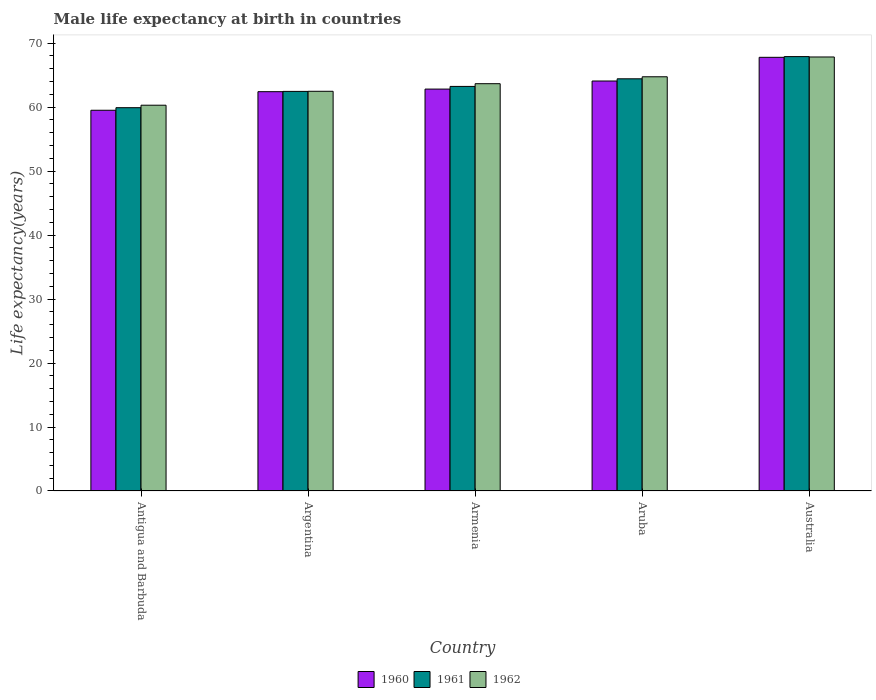How many different coloured bars are there?
Your answer should be very brief. 3. Are the number of bars per tick equal to the number of legend labels?
Offer a terse response. Yes. Are the number of bars on each tick of the X-axis equal?
Give a very brief answer. Yes. How many bars are there on the 2nd tick from the right?
Your answer should be compact. 3. What is the label of the 2nd group of bars from the left?
Offer a terse response. Argentina. In how many cases, is the number of bars for a given country not equal to the number of legend labels?
Provide a succinct answer. 0. What is the male life expectancy at birth in 1962 in Aruba?
Make the answer very short. 64.75. Across all countries, what is the maximum male life expectancy at birth in 1960?
Offer a terse response. 67.79. Across all countries, what is the minimum male life expectancy at birth in 1960?
Offer a very short reply. 59.51. In which country was the male life expectancy at birth in 1961 maximum?
Provide a short and direct response. Australia. In which country was the male life expectancy at birth in 1961 minimum?
Your answer should be compact. Antigua and Barbuda. What is the total male life expectancy at birth in 1962 in the graph?
Give a very brief answer. 319.03. What is the difference between the male life expectancy at birth in 1960 in Aruba and that in Australia?
Provide a succinct answer. -3.7. What is the difference between the male life expectancy at birth in 1961 in Aruba and the male life expectancy at birth in 1962 in Argentina?
Offer a terse response. 1.95. What is the average male life expectancy at birth in 1960 per country?
Give a very brief answer. 63.32. What is the difference between the male life expectancy at birth of/in 1962 and male life expectancy at birth of/in 1961 in Armenia?
Make the answer very short. 0.42. What is the ratio of the male life expectancy at birth in 1961 in Antigua and Barbuda to that in Argentina?
Provide a short and direct response. 0.96. Is the male life expectancy at birth in 1961 in Argentina less than that in Aruba?
Make the answer very short. Yes. What is the difference between the highest and the second highest male life expectancy at birth in 1962?
Offer a very short reply. -3.09. What is the difference between the highest and the lowest male life expectancy at birth in 1962?
Offer a terse response. 7.54. Is the sum of the male life expectancy at birth in 1961 in Argentina and Australia greater than the maximum male life expectancy at birth in 1962 across all countries?
Provide a succinct answer. Yes. What does the 3rd bar from the left in Australia represents?
Provide a succinct answer. 1962. What does the 3rd bar from the right in Australia represents?
Your answer should be compact. 1960. Is it the case that in every country, the sum of the male life expectancy at birth in 1962 and male life expectancy at birth in 1961 is greater than the male life expectancy at birth in 1960?
Provide a short and direct response. Yes. How many bars are there?
Your answer should be very brief. 15. Are all the bars in the graph horizontal?
Offer a terse response. No. Does the graph contain any zero values?
Your response must be concise. No. Where does the legend appear in the graph?
Make the answer very short. Bottom center. How many legend labels are there?
Provide a short and direct response. 3. What is the title of the graph?
Ensure brevity in your answer.  Male life expectancy at birth in countries. Does "1965" appear as one of the legend labels in the graph?
Keep it short and to the point. No. What is the label or title of the Y-axis?
Your answer should be compact. Life expectancy(years). What is the Life expectancy(years) of 1960 in Antigua and Barbuda?
Make the answer very short. 59.51. What is the Life expectancy(years) in 1961 in Antigua and Barbuda?
Offer a terse response. 59.91. What is the Life expectancy(years) in 1962 in Antigua and Barbuda?
Provide a succinct answer. 60.3. What is the Life expectancy(years) in 1960 in Argentina?
Keep it short and to the point. 62.42. What is the Life expectancy(years) of 1961 in Argentina?
Make the answer very short. 62.46. What is the Life expectancy(years) in 1962 in Argentina?
Your answer should be compact. 62.48. What is the Life expectancy(years) in 1960 in Armenia?
Your response must be concise. 62.82. What is the Life expectancy(years) of 1961 in Armenia?
Your answer should be very brief. 63.24. What is the Life expectancy(years) of 1962 in Armenia?
Keep it short and to the point. 63.66. What is the Life expectancy(years) of 1960 in Aruba?
Keep it short and to the point. 64.08. What is the Life expectancy(years) in 1961 in Aruba?
Make the answer very short. 64.43. What is the Life expectancy(years) of 1962 in Aruba?
Provide a short and direct response. 64.75. What is the Life expectancy(years) of 1960 in Australia?
Offer a very short reply. 67.79. What is the Life expectancy(years) in 1961 in Australia?
Your response must be concise. 67.9. What is the Life expectancy(years) in 1962 in Australia?
Offer a terse response. 67.84. Across all countries, what is the maximum Life expectancy(years) of 1960?
Offer a terse response. 67.79. Across all countries, what is the maximum Life expectancy(years) in 1961?
Provide a succinct answer. 67.9. Across all countries, what is the maximum Life expectancy(years) of 1962?
Provide a short and direct response. 67.84. Across all countries, what is the minimum Life expectancy(years) of 1960?
Your answer should be very brief. 59.51. Across all countries, what is the minimum Life expectancy(years) in 1961?
Give a very brief answer. 59.91. Across all countries, what is the minimum Life expectancy(years) of 1962?
Make the answer very short. 60.3. What is the total Life expectancy(years) of 1960 in the graph?
Your answer should be very brief. 316.62. What is the total Life expectancy(years) of 1961 in the graph?
Provide a short and direct response. 317.94. What is the total Life expectancy(years) in 1962 in the graph?
Keep it short and to the point. 319.03. What is the difference between the Life expectancy(years) in 1960 in Antigua and Barbuda and that in Argentina?
Your answer should be compact. -2.9. What is the difference between the Life expectancy(years) in 1961 in Antigua and Barbuda and that in Argentina?
Ensure brevity in your answer.  -2.55. What is the difference between the Life expectancy(years) of 1962 in Antigua and Barbuda and that in Argentina?
Ensure brevity in your answer.  -2.18. What is the difference between the Life expectancy(years) of 1960 in Antigua and Barbuda and that in Armenia?
Ensure brevity in your answer.  -3.31. What is the difference between the Life expectancy(years) of 1961 in Antigua and Barbuda and that in Armenia?
Keep it short and to the point. -3.33. What is the difference between the Life expectancy(years) of 1962 in Antigua and Barbuda and that in Armenia?
Provide a short and direct response. -3.36. What is the difference between the Life expectancy(years) of 1960 in Antigua and Barbuda and that in Aruba?
Your answer should be compact. -4.57. What is the difference between the Life expectancy(years) of 1961 in Antigua and Barbuda and that in Aruba?
Offer a terse response. -4.52. What is the difference between the Life expectancy(years) in 1962 in Antigua and Barbuda and that in Aruba?
Offer a very short reply. -4.45. What is the difference between the Life expectancy(years) in 1960 in Antigua and Barbuda and that in Australia?
Provide a short and direct response. -8.27. What is the difference between the Life expectancy(years) of 1961 in Antigua and Barbuda and that in Australia?
Keep it short and to the point. -7.99. What is the difference between the Life expectancy(years) of 1962 in Antigua and Barbuda and that in Australia?
Offer a very short reply. -7.54. What is the difference between the Life expectancy(years) of 1960 in Argentina and that in Armenia?
Provide a succinct answer. -0.41. What is the difference between the Life expectancy(years) of 1961 in Argentina and that in Armenia?
Give a very brief answer. -0.78. What is the difference between the Life expectancy(years) in 1962 in Argentina and that in Armenia?
Provide a short and direct response. -1.19. What is the difference between the Life expectancy(years) in 1960 in Argentina and that in Aruba?
Your answer should be very brief. -1.67. What is the difference between the Life expectancy(years) in 1961 in Argentina and that in Aruba?
Give a very brief answer. -1.97. What is the difference between the Life expectancy(years) of 1962 in Argentina and that in Aruba?
Your answer should be compact. -2.27. What is the difference between the Life expectancy(years) in 1960 in Argentina and that in Australia?
Offer a terse response. -5.37. What is the difference between the Life expectancy(years) of 1961 in Argentina and that in Australia?
Keep it short and to the point. -5.44. What is the difference between the Life expectancy(years) in 1962 in Argentina and that in Australia?
Offer a terse response. -5.36. What is the difference between the Life expectancy(years) in 1960 in Armenia and that in Aruba?
Provide a short and direct response. -1.26. What is the difference between the Life expectancy(years) of 1961 in Armenia and that in Aruba?
Your response must be concise. -1.19. What is the difference between the Life expectancy(years) in 1962 in Armenia and that in Aruba?
Keep it short and to the point. -1.08. What is the difference between the Life expectancy(years) of 1960 in Armenia and that in Australia?
Keep it short and to the point. -4.96. What is the difference between the Life expectancy(years) in 1961 in Armenia and that in Australia?
Make the answer very short. -4.66. What is the difference between the Life expectancy(years) of 1962 in Armenia and that in Australia?
Give a very brief answer. -4.18. What is the difference between the Life expectancy(years) in 1960 in Aruba and that in Australia?
Ensure brevity in your answer.  -3.7. What is the difference between the Life expectancy(years) in 1961 in Aruba and that in Australia?
Provide a short and direct response. -3.47. What is the difference between the Life expectancy(years) in 1962 in Aruba and that in Australia?
Offer a very short reply. -3.09. What is the difference between the Life expectancy(years) of 1960 in Antigua and Barbuda and the Life expectancy(years) of 1961 in Argentina?
Provide a short and direct response. -2.95. What is the difference between the Life expectancy(years) in 1960 in Antigua and Barbuda and the Life expectancy(years) in 1962 in Argentina?
Your answer should be compact. -2.96. What is the difference between the Life expectancy(years) of 1961 in Antigua and Barbuda and the Life expectancy(years) of 1962 in Argentina?
Provide a short and direct response. -2.56. What is the difference between the Life expectancy(years) of 1960 in Antigua and Barbuda and the Life expectancy(years) of 1961 in Armenia?
Your response must be concise. -3.73. What is the difference between the Life expectancy(years) in 1960 in Antigua and Barbuda and the Life expectancy(years) in 1962 in Armenia?
Make the answer very short. -4.15. What is the difference between the Life expectancy(years) in 1961 in Antigua and Barbuda and the Life expectancy(years) in 1962 in Armenia?
Give a very brief answer. -3.75. What is the difference between the Life expectancy(years) of 1960 in Antigua and Barbuda and the Life expectancy(years) of 1961 in Aruba?
Provide a succinct answer. -4.92. What is the difference between the Life expectancy(years) of 1960 in Antigua and Barbuda and the Life expectancy(years) of 1962 in Aruba?
Provide a short and direct response. -5.24. What is the difference between the Life expectancy(years) of 1961 in Antigua and Barbuda and the Life expectancy(years) of 1962 in Aruba?
Your response must be concise. -4.83. What is the difference between the Life expectancy(years) in 1960 in Antigua and Barbuda and the Life expectancy(years) in 1961 in Australia?
Provide a succinct answer. -8.39. What is the difference between the Life expectancy(years) of 1960 in Antigua and Barbuda and the Life expectancy(years) of 1962 in Australia?
Provide a short and direct response. -8.33. What is the difference between the Life expectancy(years) in 1961 in Antigua and Barbuda and the Life expectancy(years) in 1962 in Australia?
Provide a succinct answer. -7.93. What is the difference between the Life expectancy(years) of 1960 in Argentina and the Life expectancy(years) of 1961 in Armenia?
Your response must be concise. -0.82. What is the difference between the Life expectancy(years) of 1960 in Argentina and the Life expectancy(years) of 1962 in Armenia?
Your answer should be very brief. -1.25. What is the difference between the Life expectancy(years) of 1961 in Argentina and the Life expectancy(years) of 1962 in Armenia?
Give a very brief answer. -1.21. What is the difference between the Life expectancy(years) of 1960 in Argentina and the Life expectancy(years) of 1961 in Aruba?
Offer a terse response. -2.01. What is the difference between the Life expectancy(years) of 1960 in Argentina and the Life expectancy(years) of 1962 in Aruba?
Ensure brevity in your answer.  -2.33. What is the difference between the Life expectancy(years) of 1961 in Argentina and the Life expectancy(years) of 1962 in Aruba?
Provide a short and direct response. -2.29. What is the difference between the Life expectancy(years) of 1960 in Argentina and the Life expectancy(years) of 1961 in Australia?
Provide a short and direct response. -5.48. What is the difference between the Life expectancy(years) of 1960 in Argentina and the Life expectancy(years) of 1962 in Australia?
Provide a short and direct response. -5.42. What is the difference between the Life expectancy(years) of 1961 in Argentina and the Life expectancy(years) of 1962 in Australia?
Offer a terse response. -5.38. What is the difference between the Life expectancy(years) in 1960 in Armenia and the Life expectancy(years) in 1961 in Aruba?
Your response must be concise. -1.61. What is the difference between the Life expectancy(years) of 1960 in Armenia and the Life expectancy(years) of 1962 in Aruba?
Offer a very short reply. -1.93. What is the difference between the Life expectancy(years) of 1961 in Armenia and the Life expectancy(years) of 1962 in Aruba?
Your answer should be compact. -1.51. What is the difference between the Life expectancy(years) of 1960 in Armenia and the Life expectancy(years) of 1961 in Australia?
Your response must be concise. -5.08. What is the difference between the Life expectancy(years) of 1960 in Armenia and the Life expectancy(years) of 1962 in Australia?
Your answer should be very brief. -5.02. What is the difference between the Life expectancy(years) in 1961 in Armenia and the Life expectancy(years) in 1962 in Australia?
Provide a short and direct response. -4.6. What is the difference between the Life expectancy(years) in 1960 in Aruba and the Life expectancy(years) in 1961 in Australia?
Offer a very short reply. -3.82. What is the difference between the Life expectancy(years) of 1960 in Aruba and the Life expectancy(years) of 1962 in Australia?
Ensure brevity in your answer.  -3.76. What is the difference between the Life expectancy(years) in 1961 in Aruba and the Life expectancy(years) in 1962 in Australia?
Ensure brevity in your answer.  -3.41. What is the average Life expectancy(years) in 1960 per country?
Give a very brief answer. 63.32. What is the average Life expectancy(years) of 1961 per country?
Your answer should be very brief. 63.59. What is the average Life expectancy(years) in 1962 per country?
Provide a short and direct response. 63.81. What is the difference between the Life expectancy(years) of 1960 and Life expectancy(years) of 1962 in Antigua and Barbuda?
Your answer should be compact. -0.79. What is the difference between the Life expectancy(years) of 1961 and Life expectancy(years) of 1962 in Antigua and Barbuda?
Ensure brevity in your answer.  -0.39. What is the difference between the Life expectancy(years) in 1960 and Life expectancy(years) in 1961 in Argentina?
Provide a succinct answer. -0.04. What is the difference between the Life expectancy(years) in 1960 and Life expectancy(years) in 1962 in Argentina?
Your response must be concise. -0.06. What is the difference between the Life expectancy(years) of 1961 and Life expectancy(years) of 1962 in Argentina?
Offer a very short reply. -0.02. What is the difference between the Life expectancy(years) of 1960 and Life expectancy(years) of 1961 in Armenia?
Your response must be concise. -0.42. What is the difference between the Life expectancy(years) of 1960 and Life expectancy(years) of 1962 in Armenia?
Offer a terse response. -0.84. What is the difference between the Life expectancy(years) in 1961 and Life expectancy(years) in 1962 in Armenia?
Provide a succinct answer. -0.42. What is the difference between the Life expectancy(years) in 1960 and Life expectancy(years) in 1961 in Aruba?
Make the answer very short. -0.34. What is the difference between the Life expectancy(years) in 1960 and Life expectancy(years) in 1962 in Aruba?
Offer a terse response. -0.66. What is the difference between the Life expectancy(years) of 1961 and Life expectancy(years) of 1962 in Aruba?
Give a very brief answer. -0.32. What is the difference between the Life expectancy(years) of 1960 and Life expectancy(years) of 1961 in Australia?
Your answer should be compact. -0.11. What is the difference between the Life expectancy(years) of 1960 and Life expectancy(years) of 1962 in Australia?
Give a very brief answer. -0.05. What is the ratio of the Life expectancy(years) of 1960 in Antigua and Barbuda to that in Argentina?
Offer a very short reply. 0.95. What is the ratio of the Life expectancy(years) of 1961 in Antigua and Barbuda to that in Argentina?
Your answer should be compact. 0.96. What is the ratio of the Life expectancy(years) of 1962 in Antigua and Barbuda to that in Argentina?
Offer a terse response. 0.97. What is the ratio of the Life expectancy(years) of 1960 in Antigua and Barbuda to that in Armenia?
Offer a terse response. 0.95. What is the ratio of the Life expectancy(years) of 1961 in Antigua and Barbuda to that in Armenia?
Make the answer very short. 0.95. What is the ratio of the Life expectancy(years) of 1962 in Antigua and Barbuda to that in Armenia?
Ensure brevity in your answer.  0.95. What is the ratio of the Life expectancy(years) of 1960 in Antigua and Barbuda to that in Aruba?
Your answer should be compact. 0.93. What is the ratio of the Life expectancy(years) of 1961 in Antigua and Barbuda to that in Aruba?
Your answer should be compact. 0.93. What is the ratio of the Life expectancy(years) in 1962 in Antigua and Barbuda to that in Aruba?
Provide a short and direct response. 0.93. What is the ratio of the Life expectancy(years) in 1960 in Antigua and Barbuda to that in Australia?
Your response must be concise. 0.88. What is the ratio of the Life expectancy(years) of 1961 in Antigua and Barbuda to that in Australia?
Offer a terse response. 0.88. What is the ratio of the Life expectancy(years) in 1962 in Antigua and Barbuda to that in Australia?
Your response must be concise. 0.89. What is the ratio of the Life expectancy(years) of 1960 in Argentina to that in Armenia?
Give a very brief answer. 0.99. What is the ratio of the Life expectancy(years) of 1962 in Argentina to that in Armenia?
Your answer should be compact. 0.98. What is the ratio of the Life expectancy(years) in 1961 in Argentina to that in Aruba?
Ensure brevity in your answer.  0.97. What is the ratio of the Life expectancy(years) in 1962 in Argentina to that in Aruba?
Your answer should be very brief. 0.96. What is the ratio of the Life expectancy(years) of 1960 in Argentina to that in Australia?
Offer a terse response. 0.92. What is the ratio of the Life expectancy(years) of 1961 in Argentina to that in Australia?
Provide a succinct answer. 0.92. What is the ratio of the Life expectancy(years) in 1962 in Argentina to that in Australia?
Provide a short and direct response. 0.92. What is the ratio of the Life expectancy(years) in 1960 in Armenia to that in Aruba?
Provide a short and direct response. 0.98. What is the ratio of the Life expectancy(years) of 1961 in Armenia to that in Aruba?
Offer a terse response. 0.98. What is the ratio of the Life expectancy(years) of 1962 in Armenia to that in Aruba?
Keep it short and to the point. 0.98. What is the ratio of the Life expectancy(years) in 1960 in Armenia to that in Australia?
Keep it short and to the point. 0.93. What is the ratio of the Life expectancy(years) of 1961 in Armenia to that in Australia?
Offer a very short reply. 0.93. What is the ratio of the Life expectancy(years) in 1962 in Armenia to that in Australia?
Your answer should be compact. 0.94. What is the ratio of the Life expectancy(years) in 1960 in Aruba to that in Australia?
Offer a very short reply. 0.95. What is the ratio of the Life expectancy(years) in 1961 in Aruba to that in Australia?
Your response must be concise. 0.95. What is the ratio of the Life expectancy(years) in 1962 in Aruba to that in Australia?
Provide a succinct answer. 0.95. What is the difference between the highest and the second highest Life expectancy(years) of 1960?
Your answer should be very brief. 3.7. What is the difference between the highest and the second highest Life expectancy(years) of 1961?
Give a very brief answer. 3.47. What is the difference between the highest and the second highest Life expectancy(years) of 1962?
Your response must be concise. 3.09. What is the difference between the highest and the lowest Life expectancy(years) of 1960?
Offer a very short reply. 8.27. What is the difference between the highest and the lowest Life expectancy(years) in 1961?
Provide a short and direct response. 7.99. What is the difference between the highest and the lowest Life expectancy(years) of 1962?
Give a very brief answer. 7.54. 